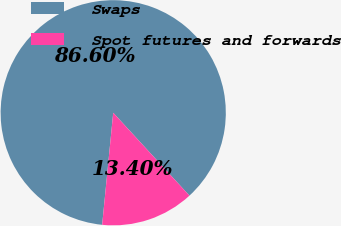Convert chart to OTSL. <chart><loc_0><loc_0><loc_500><loc_500><pie_chart><fcel>Swaps<fcel>Spot futures and forwards<nl><fcel>86.6%<fcel>13.4%<nl></chart> 